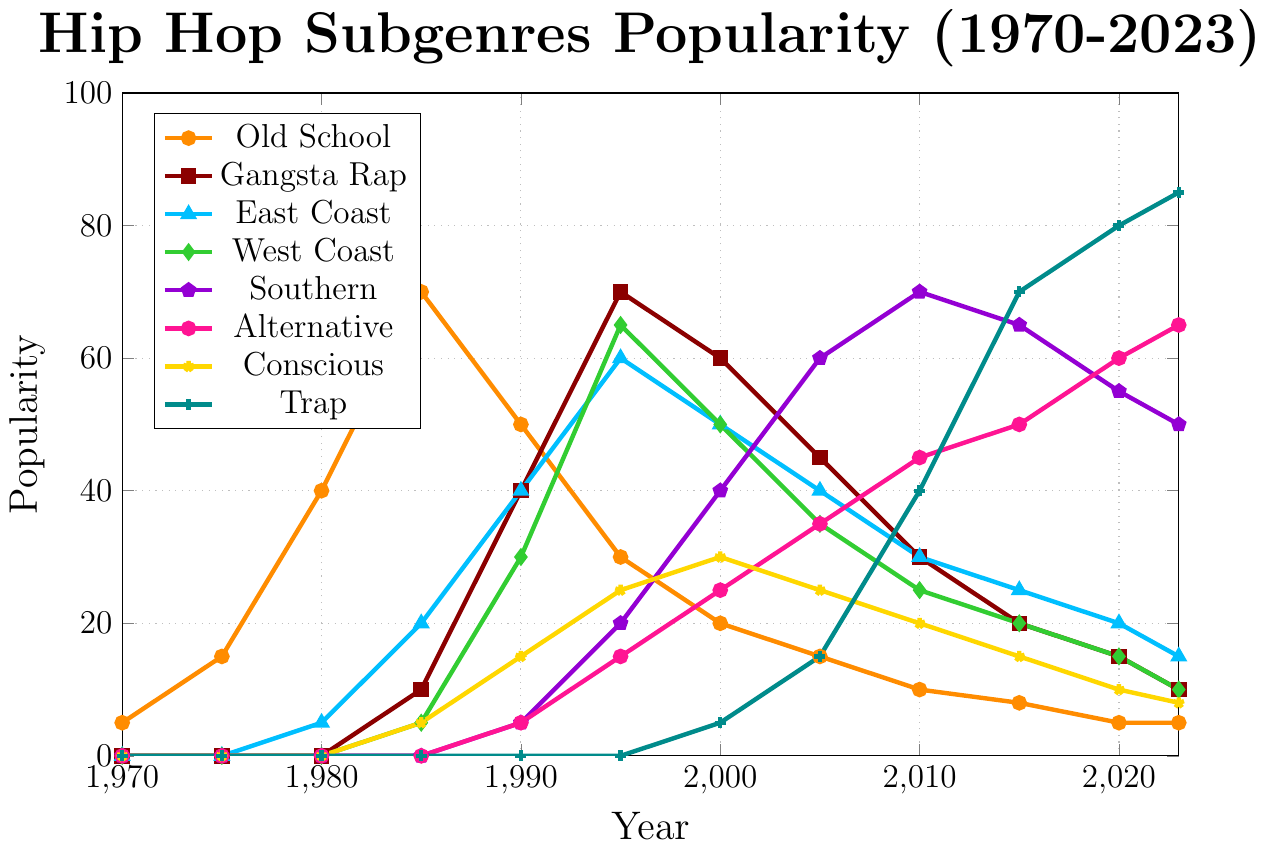Which hip hop subgenre had the highest peak in popularity? By looking at the peak points in the graph for each subgenre, Trap reaches 85 in 2023, the highest peak on the graph.
Answer: Trap Between 1990 and 2000, which subgenre experienced the most significant decrease in popularity? Comparing the changes from 1990 to 2000, Old School went from 50 to 20, a decrease of 30, which is the most significant decline.
Answer: Old School What is the combined popularity of Gangsta Rap and East Coast hip hop in 1995? Adding the popularity values of Gangsta Rap (70) and East Coast (60) in 1995, the sum is 70 + 60 = 130.
Answer: 130 During which time period did Southern hip hop see its sharpest increase in popularity? Observing the slopes of Southern hip hop, the sharpest increase is between 2000 (40) and 2005 (60), an increase of 20.
Answer: 2000-2005 How many subgenres had a popularity score of 50 or higher in 1995? In 1995, counting the subgenres with popularity values of 50 or higher: Gangsta Rap (70), East Coast (60), West Coast (65), and Southern (20). Only three subgenres meet this criteria.
Answer: 3 In 2023, which hip hop subgenre had the lowest popularity? Comparing the values in 2023, the lowest value is shared between Old School (5) and Conscious (8), making Old School the lowest.
Answer: Old School What is the trend of Conscious hip hop from 2000 to 2023? Observing Conscious hip hop values from 2000 (30) to 2023 (8), there's a downward trend.
Answer: Decreasing Which subgenre overtook Gangsta Rap in popularity first: Southern or Trap? By tracing their growth, Southern overtakes Gangsta Rap first in 2005, whereas Trap only overtakes it later.
Answer: Southern 